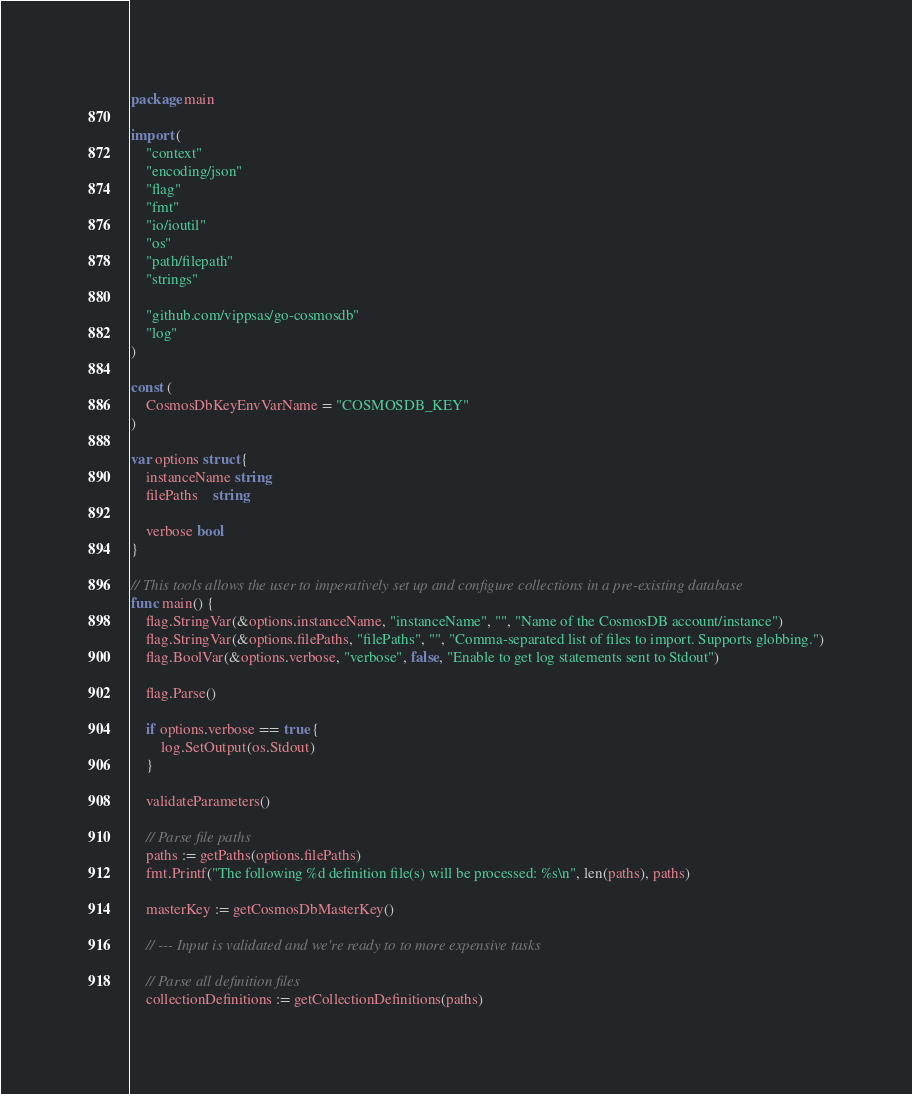Convert code to text. <code><loc_0><loc_0><loc_500><loc_500><_Go_>package main

import (
	"context"
	"encoding/json"
	"flag"
	"fmt"
	"io/ioutil"
	"os"
	"path/filepath"
	"strings"

	"github.com/vippsas/go-cosmosdb"
	"log"
)

const (
	CosmosDbKeyEnvVarName = "COSMOSDB_KEY"
)

var options struct {
	instanceName string
	filePaths    string

	verbose bool
}

// This tools allows the user to imperatively set up and configure collections in a pre-existing database
func main() {
	flag.StringVar(&options.instanceName, "instanceName", "", "Name of the CosmosDB account/instance")
	flag.StringVar(&options.filePaths, "filePaths", "", "Comma-separated list of files to import. Supports globbing.")
	flag.BoolVar(&options.verbose, "verbose", false, "Enable to get log statements sent to Stdout")

	flag.Parse()

	if options.verbose == true {
		log.SetOutput(os.Stdout)
	}

	validateParameters()

	// Parse file paths
	paths := getPaths(options.filePaths)
	fmt.Printf("The following %d definition file(s) will be processed: %s\n", len(paths), paths)

	masterKey := getCosmosDbMasterKey()

	// --- Input is validated and we're ready to to more expensive tasks

	// Parse all definition files
	collectionDefinitions := getCollectionDefinitions(paths)
</code> 